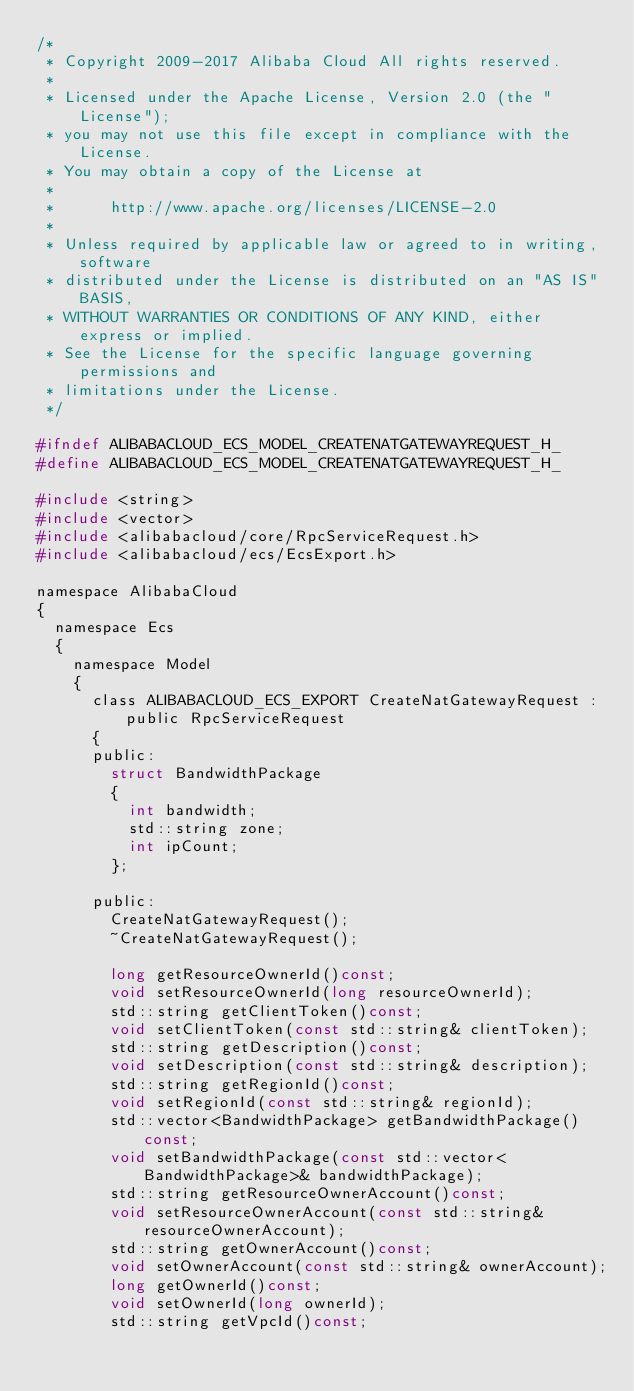Convert code to text. <code><loc_0><loc_0><loc_500><loc_500><_C_>/*
 * Copyright 2009-2017 Alibaba Cloud All rights reserved.
 * 
 * Licensed under the Apache License, Version 2.0 (the "License");
 * you may not use this file except in compliance with the License.
 * You may obtain a copy of the License at
 * 
 *      http://www.apache.org/licenses/LICENSE-2.0
 * 
 * Unless required by applicable law or agreed to in writing, software
 * distributed under the License is distributed on an "AS IS" BASIS,
 * WITHOUT WARRANTIES OR CONDITIONS OF ANY KIND, either express or implied.
 * See the License for the specific language governing permissions and
 * limitations under the License.
 */

#ifndef ALIBABACLOUD_ECS_MODEL_CREATENATGATEWAYREQUEST_H_
#define ALIBABACLOUD_ECS_MODEL_CREATENATGATEWAYREQUEST_H_

#include <string>
#include <vector>
#include <alibabacloud/core/RpcServiceRequest.h>
#include <alibabacloud/ecs/EcsExport.h>

namespace AlibabaCloud
{
	namespace Ecs
	{
		namespace Model
		{
			class ALIBABACLOUD_ECS_EXPORT CreateNatGatewayRequest : public RpcServiceRequest
			{
			public:
				struct BandwidthPackage
				{
					int bandwidth;
					std::string zone;
					int ipCount;
				};

			public:
				CreateNatGatewayRequest();
				~CreateNatGatewayRequest();

				long getResourceOwnerId()const;
				void setResourceOwnerId(long resourceOwnerId);
				std::string getClientToken()const;
				void setClientToken(const std::string& clientToken);
				std::string getDescription()const;
				void setDescription(const std::string& description);
				std::string getRegionId()const;
				void setRegionId(const std::string& regionId);
				std::vector<BandwidthPackage> getBandwidthPackage()const;
				void setBandwidthPackage(const std::vector<BandwidthPackage>& bandwidthPackage);
				std::string getResourceOwnerAccount()const;
				void setResourceOwnerAccount(const std::string& resourceOwnerAccount);
				std::string getOwnerAccount()const;
				void setOwnerAccount(const std::string& ownerAccount);
				long getOwnerId()const;
				void setOwnerId(long ownerId);
				std::string getVpcId()const;</code> 